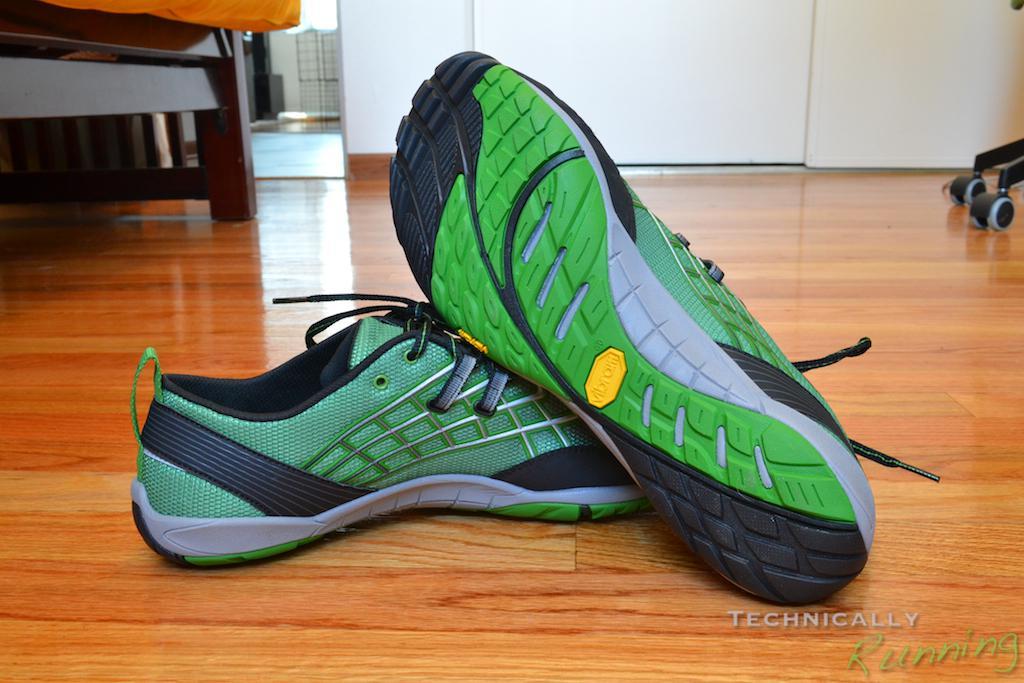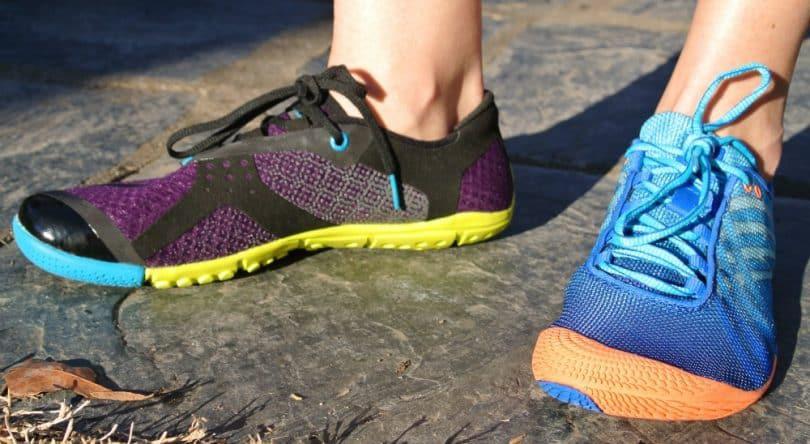The first image is the image on the left, the second image is the image on the right. Assess this claim about the two images: "One image shows a pair of feet in sneakers, and the other shows a pair of unworn shoes, one turned so its sole faces the camera.". Correct or not? Answer yes or no. Yes. The first image is the image on the left, the second image is the image on the right. Given the left and right images, does the statement "The left hand image shows both the top and the bottom of the pair of shoes that are not on a person, while the right hand image shows shoes being worn by a human." hold true? Answer yes or no. Yes. 